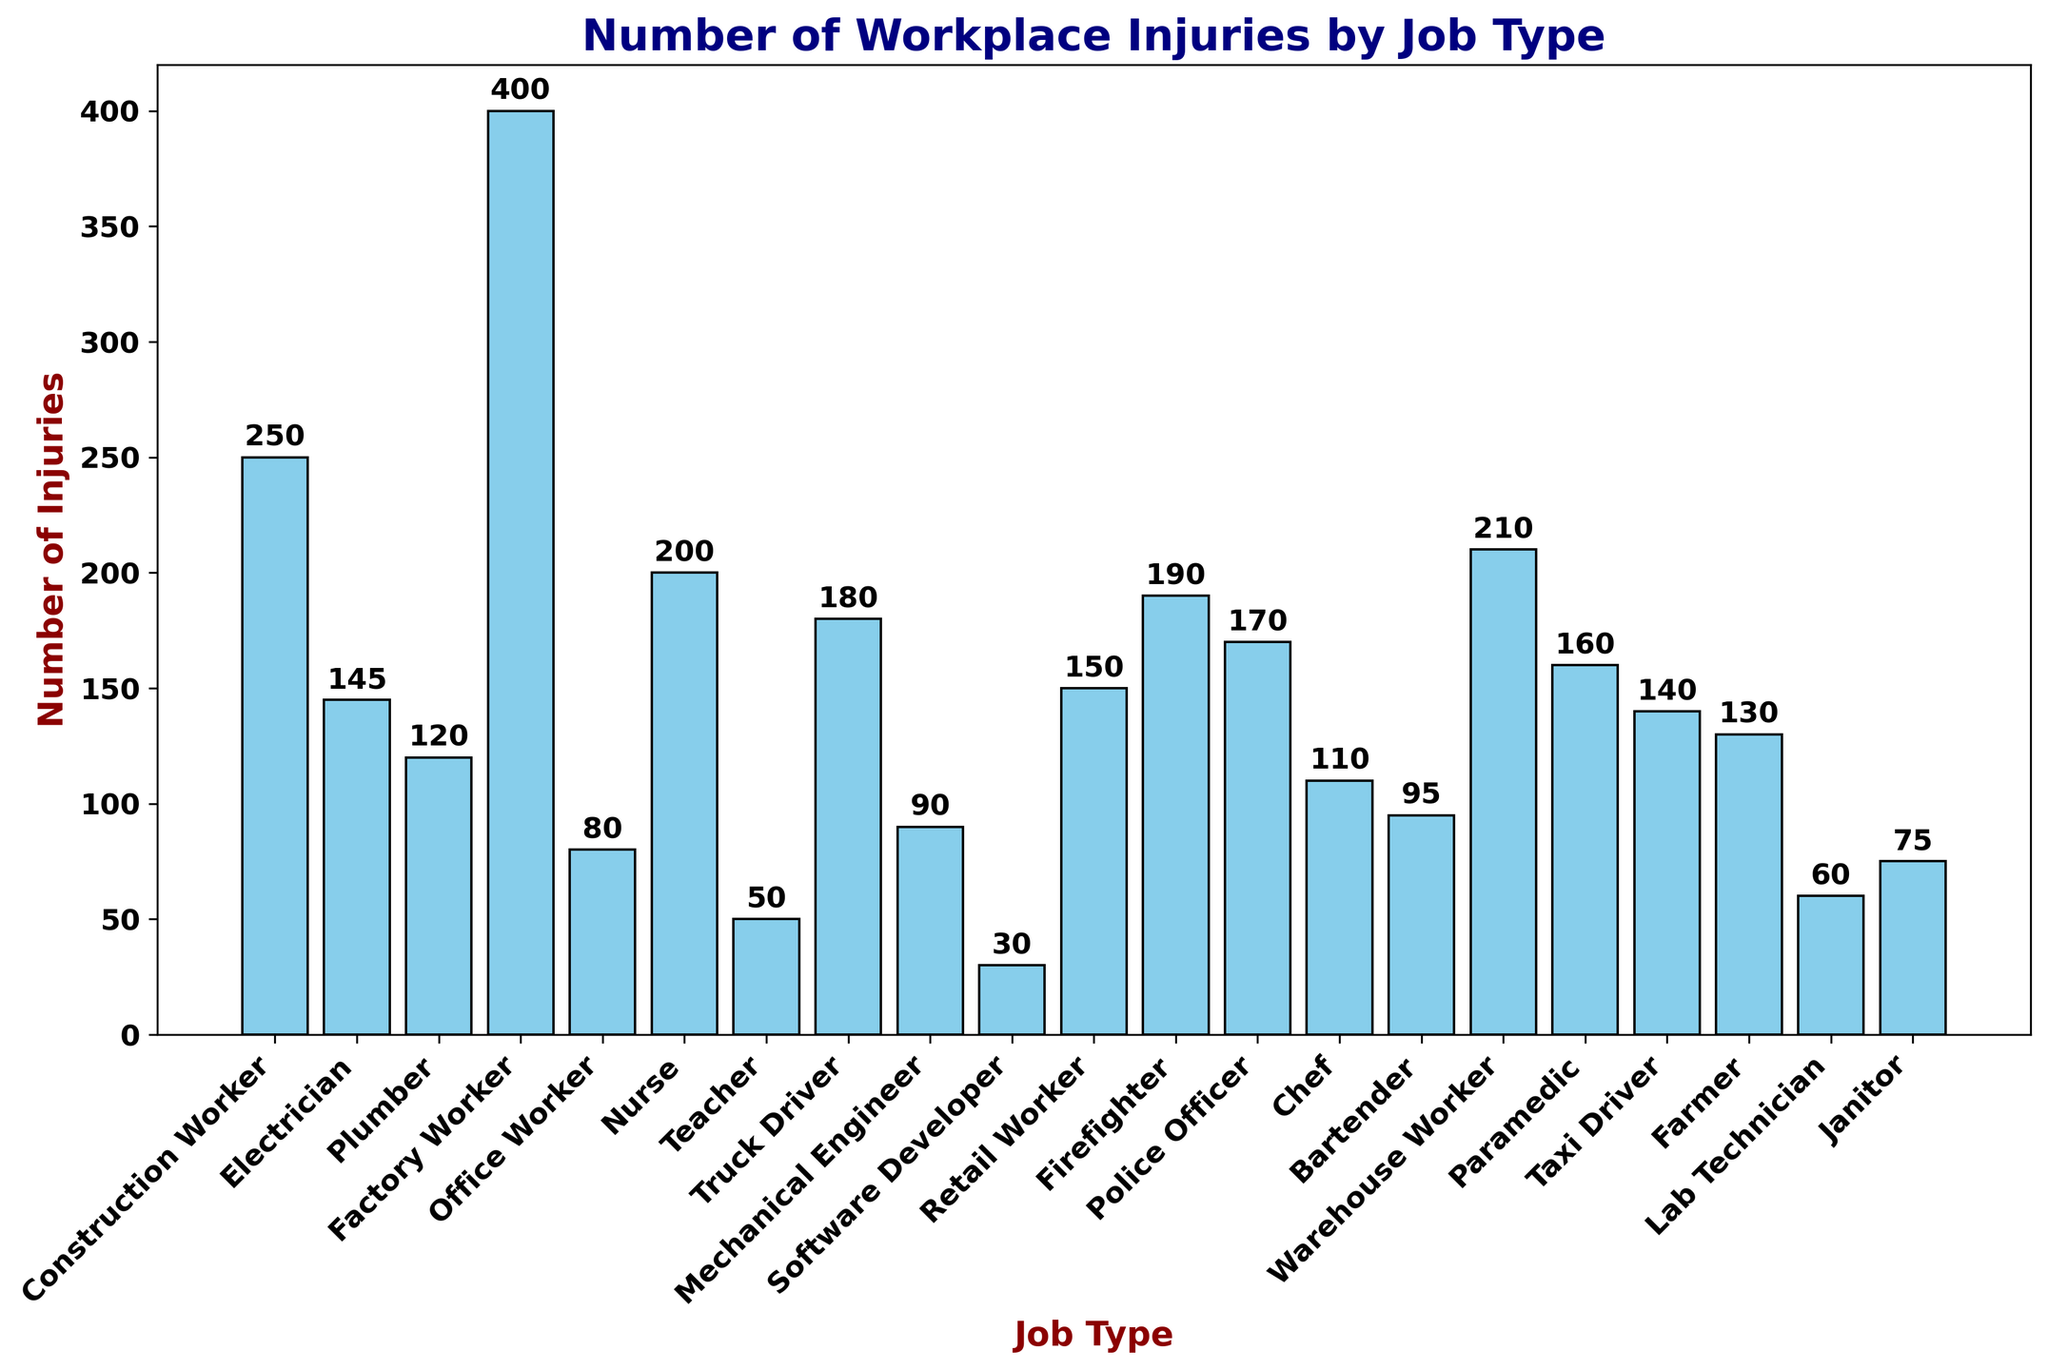Which job type has the highest number of workplace injuries? The bar representing Factory Workers is the tallest, indicating they have the highest number of workplace injuries.
Answer: Factory Worker What is the combined number of injuries for the top three job types? The top three job types in terms of injuries are Factory Worker (400), Construction Worker (250), and Nurse (200). Adding them together gives: 400 + 250 + 200 = 850.
Answer: 850 How do the number of injuries for Nurses compare to those for Firefighters? The number of injuries for Nurses is 200, while for Firefighters it is 190. Therefore, Nurses have slightly more injuries than Firefighters.
Answer: Nurses have more injuries Which job type has the fewest injuries and how many are there? The shortest bar is for Software Developers, indicating they have the fewest injuries. The number of injuries is 30.
Answer: Software Developer with 30 injuries What is the difference in number of injuries between Truck Drivers and Police Officers? Truck Drivers have 180 injuries, while Police Officers have 170 injuries. The difference is 180 - 170 = 10.
Answer: 10 How many more injuries do Warehouse Workers have compared to Bartenders? Warehouse Workers have 210 injuries, and Bartenders have 95. Subtracting these gives 210 - 95 = 115.
Answer: 115 What is the average number of injuries per job type? Summing all the injuries: 250 + 145 + 120 + 400 + 80 + 200 + 50 + 180 + 90 + 30 + 150 + 190 + 170 + 110 + 95 + 210 + 160 + 140 + 130 + 60 + 75 = 3545. There are 21 job types, so the average is 3545 / 21 ≈ 169.
Answer: 169 Which job type has injuries closest to the median number, and what is the median value? First, list the injuries in ascending order: 30, 50, 60, 75, 80, 90, 95, 110, 120, 130, 140, 145, 150, 160, 170, 180, 190, 200, 210, 250, 400. The median is the (21+1)/2 = 11th value, which is 140 for Taxi Drivers.
Answer: Taxi Driver with 140 What is the visual color utilized for the bars representing the number of injuries? The bars in the histogram are colored sky blue.
Answer: Sky blue 